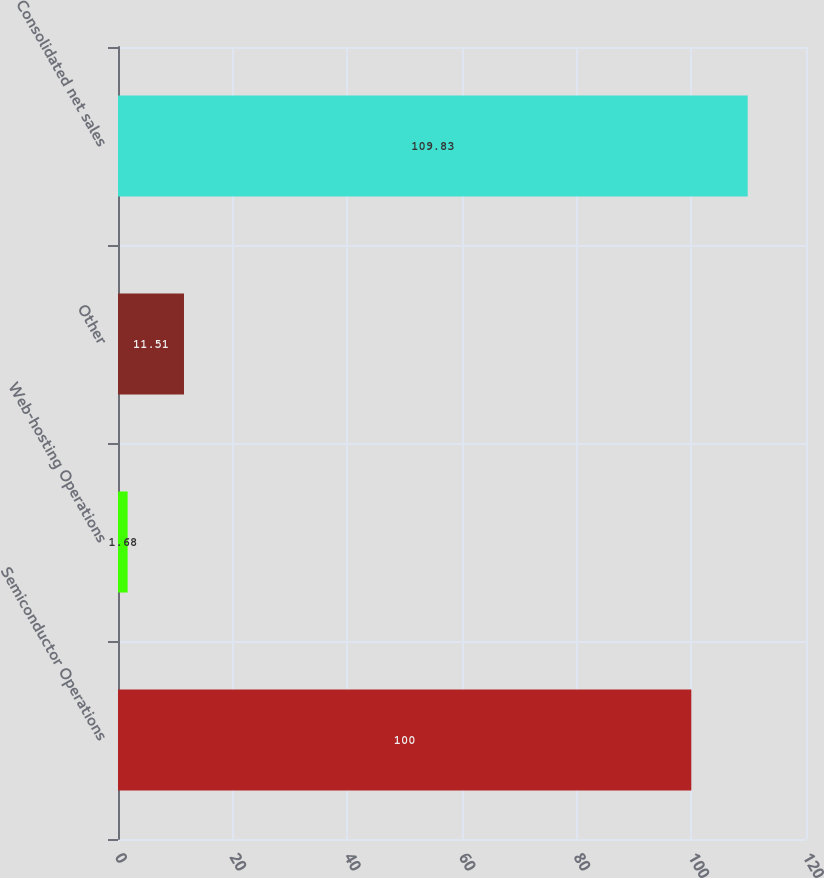<chart> <loc_0><loc_0><loc_500><loc_500><bar_chart><fcel>Semiconductor Operations<fcel>Web-hosting Operations<fcel>Other<fcel>Consolidated net sales<nl><fcel>100<fcel>1.68<fcel>11.51<fcel>109.83<nl></chart> 